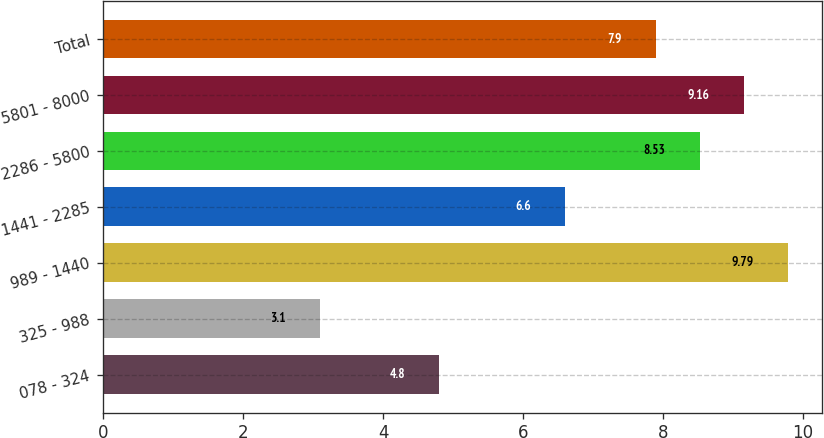Convert chart. <chart><loc_0><loc_0><loc_500><loc_500><bar_chart><fcel>078 - 324<fcel>325 - 988<fcel>989 - 1440<fcel>1441 - 2285<fcel>2286 - 5800<fcel>5801 - 8000<fcel>Total<nl><fcel>4.8<fcel>3.1<fcel>9.79<fcel>6.6<fcel>8.53<fcel>9.16<fcel>7.9<nl></chart> 